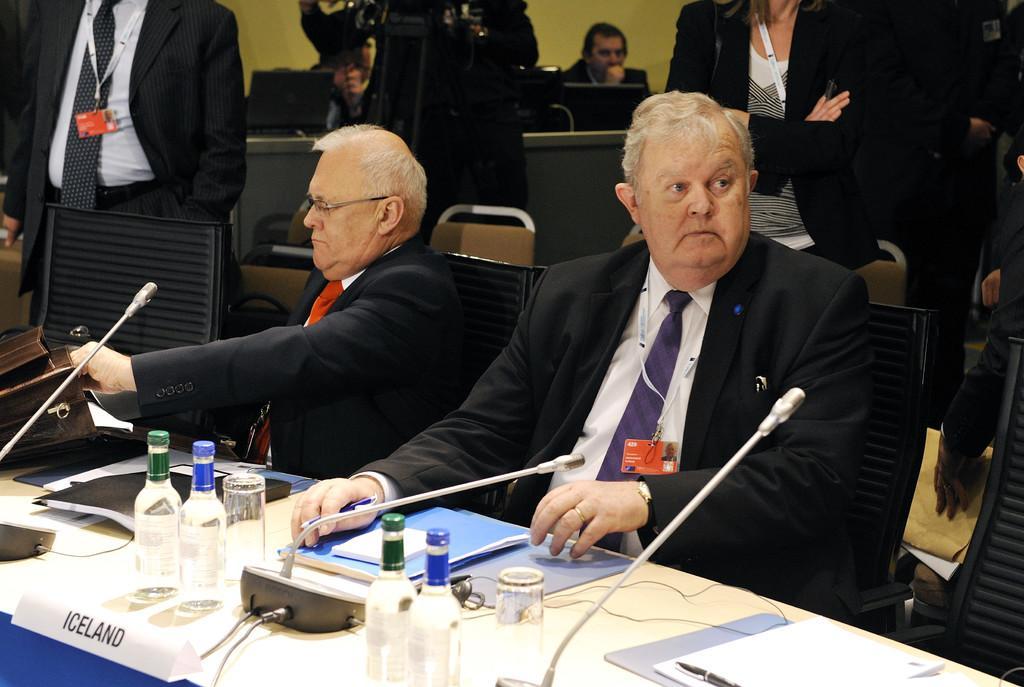In one or two sentences, can you explain what this image depicts? In the foreground of this picture we can see a table on the top of which microphones, glasses, bottles, papers and some other items are placed and we can see the group of persons sitting on the chairs and wearing suits. In the background we can see the wall and group of persons standing and we can see some other objects in the background. 